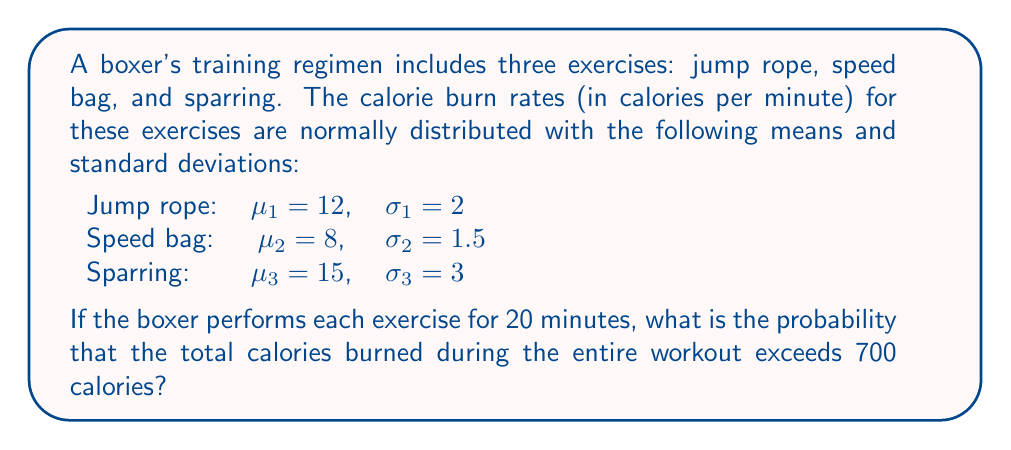Help me with this question. Let's approach this step-by-step:

1) First, we need to calculate the total mean and variance of calories burned for the entire workout.

2) For each exercise:
   Mean calories burned = time * mean rate
   Variance of calories burned = time^2 * variance of rate

3) Jump rope:
   Mean: $20 * 12 = 240$ calories
   Variance: $20^2 * 2^2 = 1600$

4) Speed bag:
   Mean: $20 * 8 = 160$ calories
   Variance: $20^2 * 1.5^2 = 900$

5) Sparring:
   Mean: $20 * 15 = 300$ calories
   Variance: $20^2 * 3^2 = 3600$

6) Total workout:
   Mean: $240 + 160 + 300 = 700$ calories
   Variance: $1600 + 900 + 3600 = 6100$
   Standard deviation: $\sqrt{6100} \approx 78.1$ calories

7) The question asks for the probability of burning more than 700 calories.

8) We can standardize this value:
   $z = \frac{700 - 700}{78.1} = 0$

9) We want $P(X > 700)$, which is equivalent to $1 - P(X \leq 700)$
   $P(X > 700) = 1 - \Phi(0) = 1 - 0.5 = 0.5$

Where $\Phi$ is the cumulative distribution function of the standard normal distribution.
Answer: 0.5 